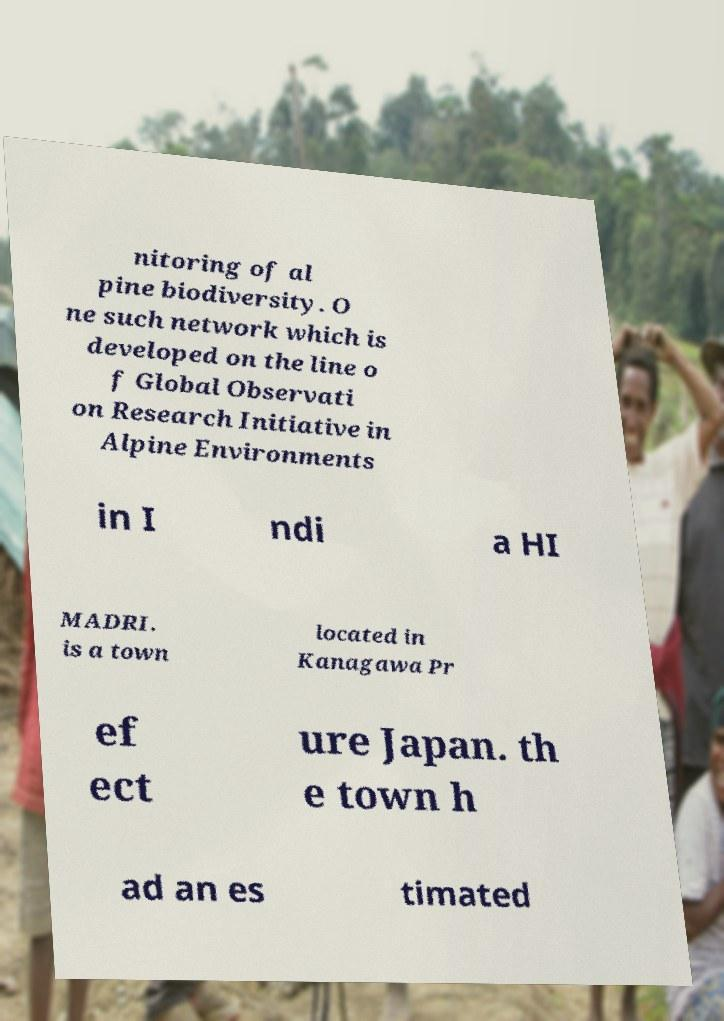Can you read and provide the text displayed in the image?This photo seems to have some interesting text. Can you extract and type it out for me? nitoring of al pine biodiversity. O ne such network which is developed on the line o f Global Observati on Research Initiative in Alpine Environments in I ndi a HI MADRI. is a town located in Kanagawa Pr ef ect ure Japan. th e town h ad an es timated 